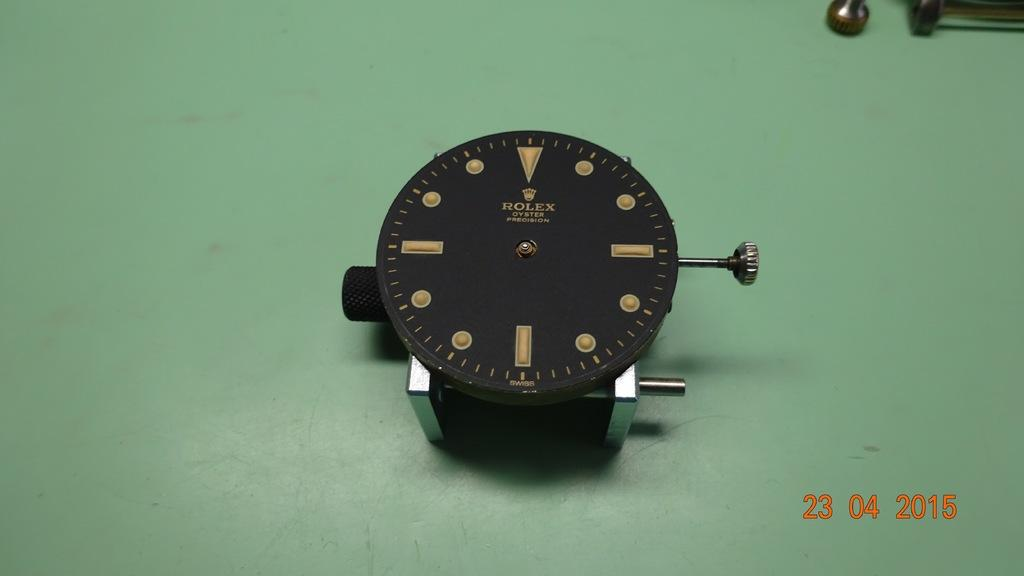<image>
Give a short and clear explanation of the subsequent image. A rolex precision clock is on display on a green table. 